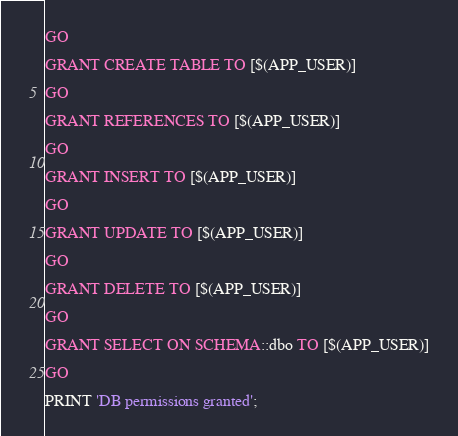Convert code to text. <code><loc_0><loc_0><loc_500><loc_500><_SQL_>GO

GRANT CREATE TABLE TO [$(APP_USER)]

GO

GRANT REFERENCES TO [$(APP_USER)]

GO

GRANT INSERT TO [$(APP_USER)]

GO

GRANT UPDATE TO [$(APP_USER)]

GO

GRANT DELETE TO [$(APP_USER)]

GO

GRANT SELECT ON SCHEMA::dbo TO [$(APP_USER)]

GO

PRINT 'DB permissions granted';
</code> 